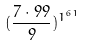<formula> <loc_0><loc_0><loc_500><loc_500>( \frac { 7 \cdot 9 9 } { 9 } ) ^ { 1 ^ { 6 1 } }</formula> 